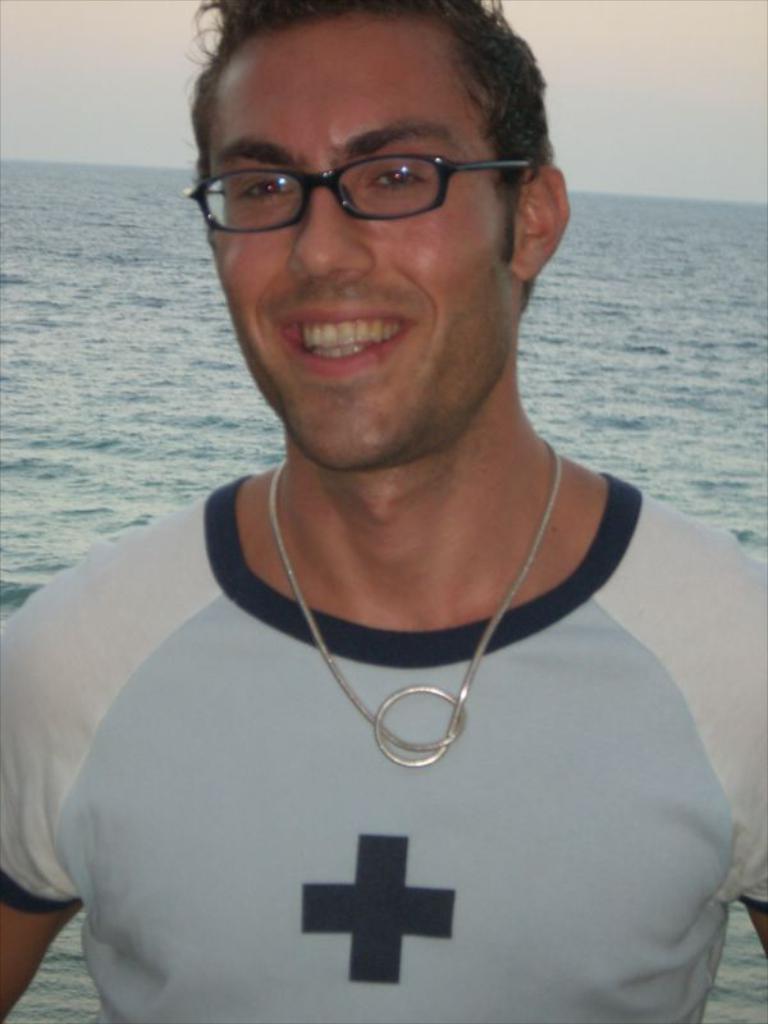Could you give a brief overview of what you see in this image? In this picture we can see a person smiling. There is water in the background. 